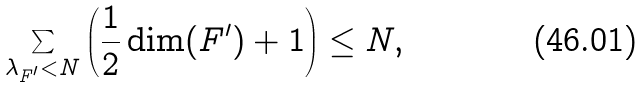<formula> <loc_0><loc_0><loc_500><loc_500>\sum _ { \lambda _ { F ^ { \prime } } < N } \left ( \frac { 1 } { 2 } \dim ( F ^ { \prime } ) + 1 \right ) \leq N ,</formula> 